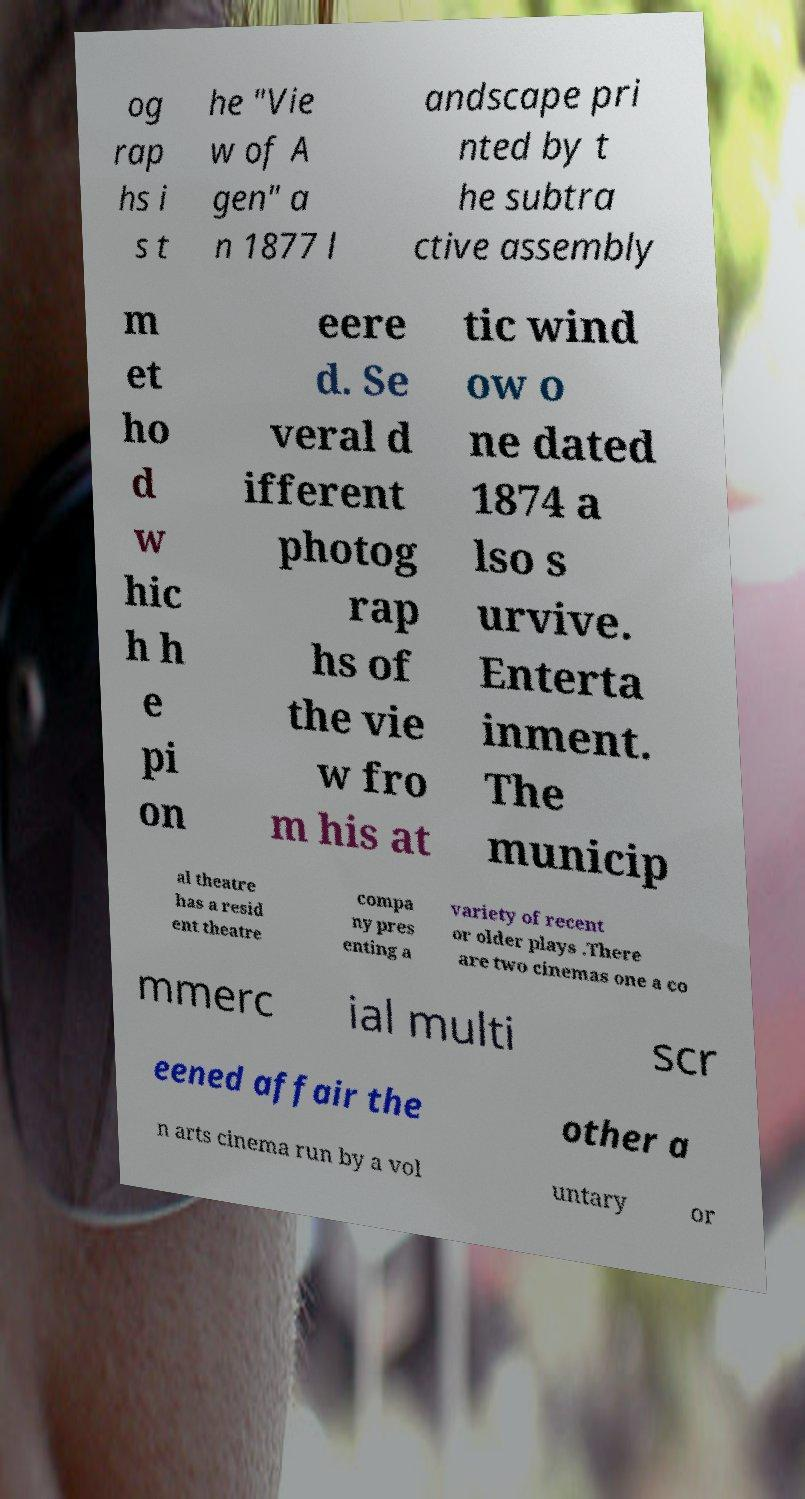For documentation purposes, I need the text within this image transcribed. Could you provide that? og rap hs i s t he "Vie w of A gen" a n 1877 l andscape pri nted by t he subtra ctive assembly m et ho d w hic h h e pi on eere d. Se veral d ifferent photog rap hs of the vie w fro m his at tic wind ow o ne dated 1874 a lso s urvive. Enterta inment. The municip al theatre has a resid ent theatre compa ny pres enting a variety of recent or older plays .There are two cinemas one a co mmerc ial multi scr eened affair the other a n arts cinema run by a vol untary or 